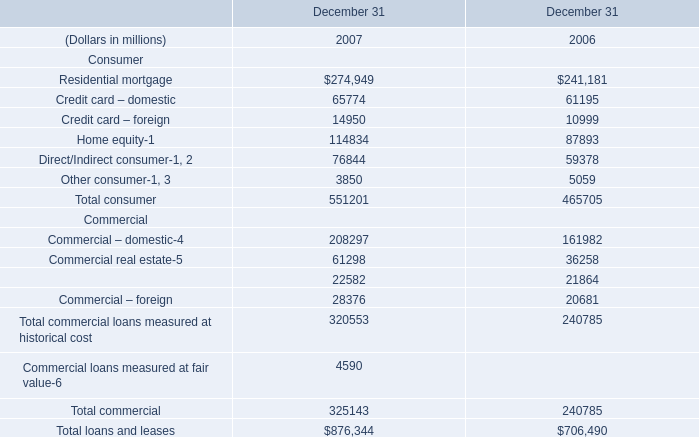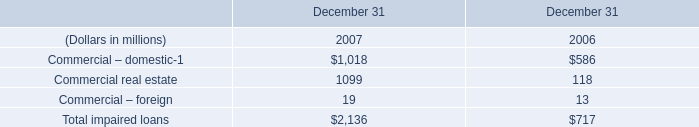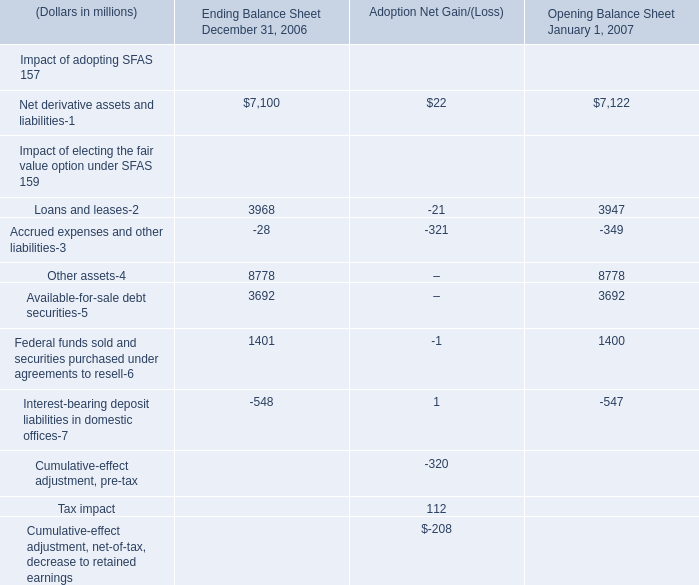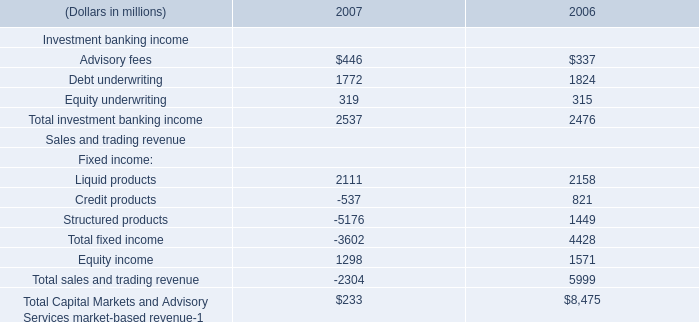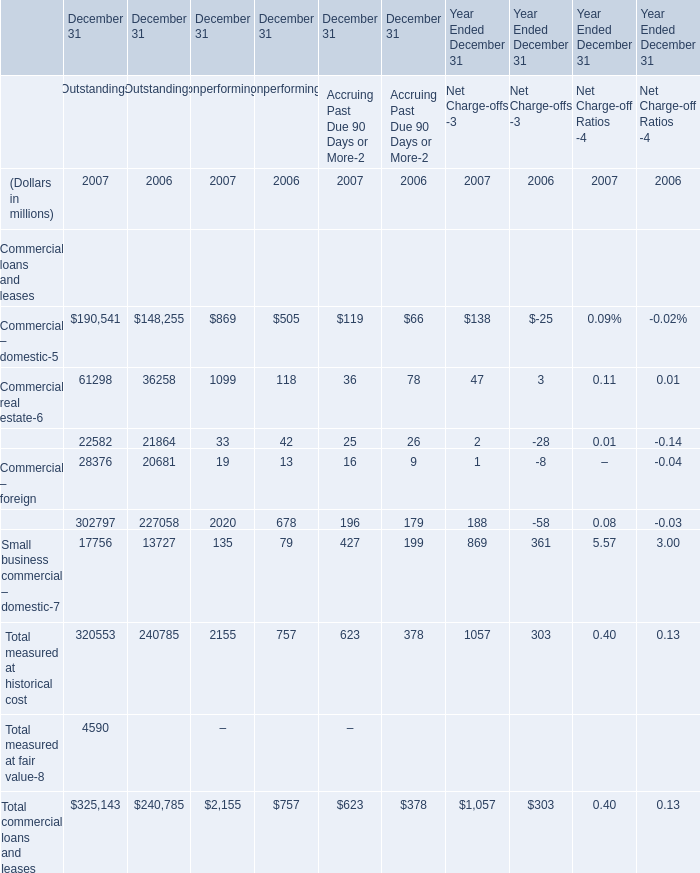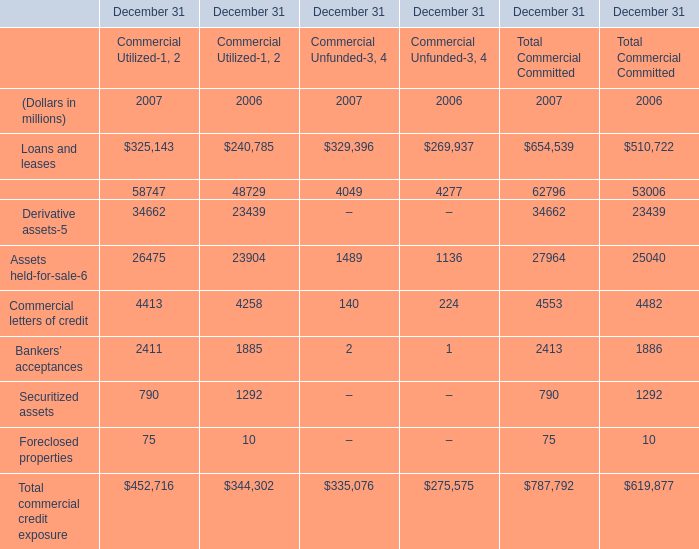What is the average amount of Residential mortgage of December 31 2006, and Loans and leases of December 31 Commercial Unfunded 2006 ? 
Computations: ((241181.0 + 269937.0) / 2)
Answer: 255559.0. 